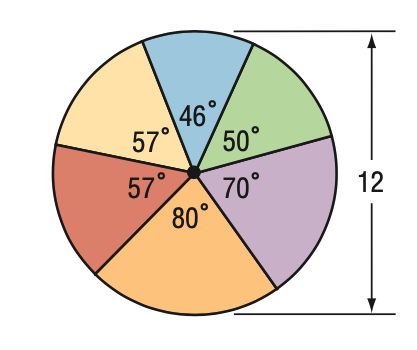Answer the mathemtical geometry problem and directly provide the correct option letter.
Question: Find the area of the blue sector.
Choices: A: 2.3 \pi B: 4.6 \pi C: 6.9 \pi D: 9.2 \pi B 